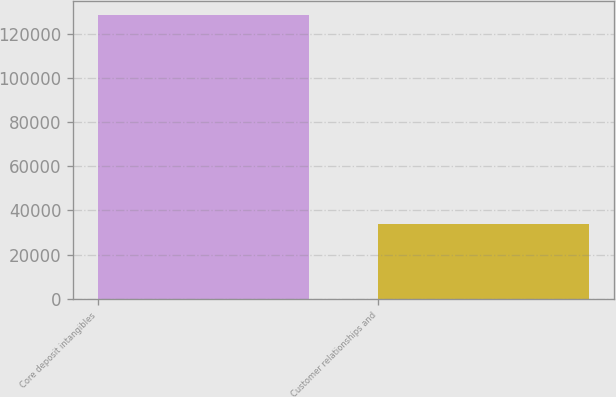Convert chart to OTSL. <chart><loc_0><loc_0><loc_500><loc_500><bar_chart><fcel>Core deposit intangibles<fcel>Customer relationships and<nl><fcel>128382<fcel>33752<nl></chart> 